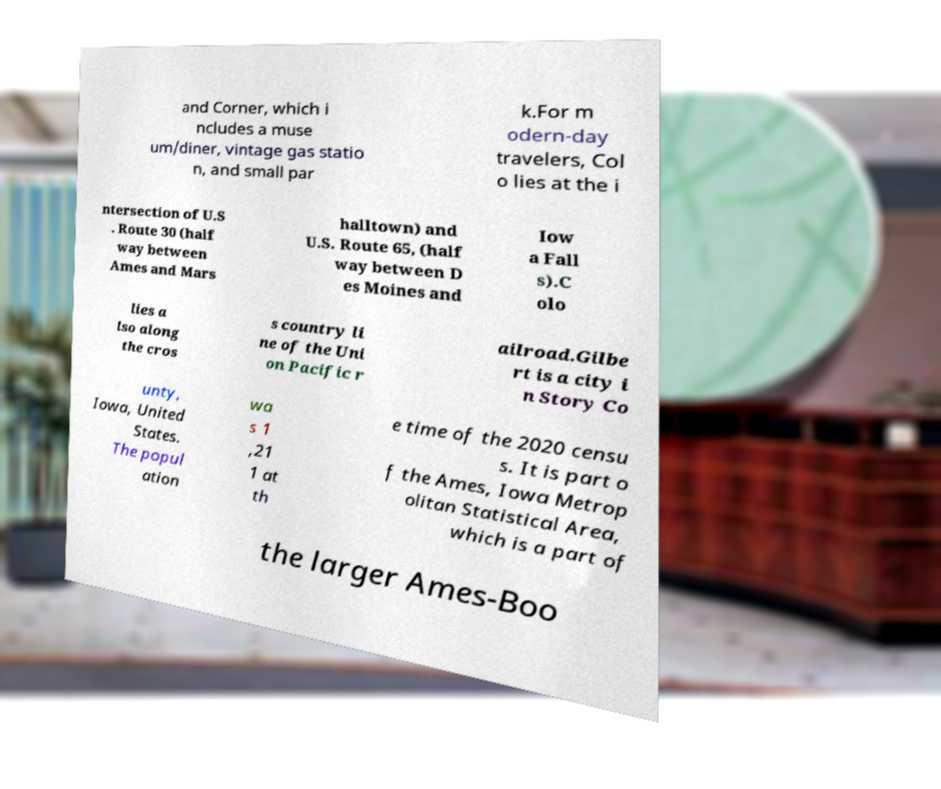Can you read and provide the text displayed in the image?This photo seems to have some interesting text. Can you extract and type it out for me? and Corner, which i ncludes a muse um/diner, vintage gas statio n, and small par k.For m odern-day travelers, Col o lies at the i ntersection of U.S . Route 30 (half way between Ames and Mars halltown) and U.S. Route 65, (half way between D es Moines and Iow a Fall s).C olo lies a lso along the cros s country li ne of the Uni on Pacific r ailroad.Gilbe rt is a city i n Story Co unty, Iowa, United States. The popul ation wa s 1 ,21 1 at th e time of the 2020 censu s. It is part o f the Ames, Iowa Metrop olitan Statistical Area, which is a part of the larger Ames-Boo 